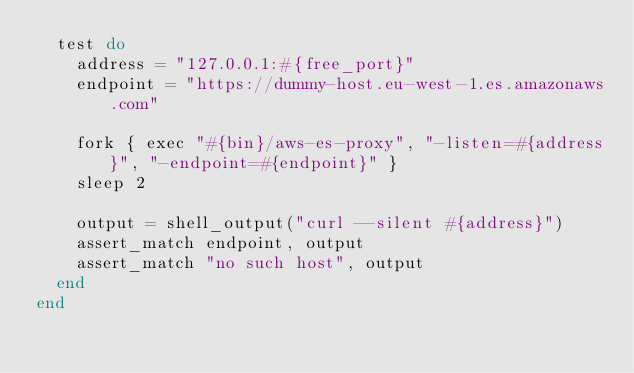Convert code to text. <code><loc_0><loc_0><loc_500><loc_500><_Ruby_>  test do
    address = "127.0.0.1:#{free_port}"
    endpoint = "https://dummy-host.eu-west-1.es.amazonaws.com"

    fork { exec "#{bin}/aws-es-proxy", "-listen=#{address}", "-endpoint=#{endpoint}" }
    sleep 2

    output = shell_output("curl --silent #{address}")
    assert_match endpoint, output
    assert_match "no such host", output
  end
end
</code> 